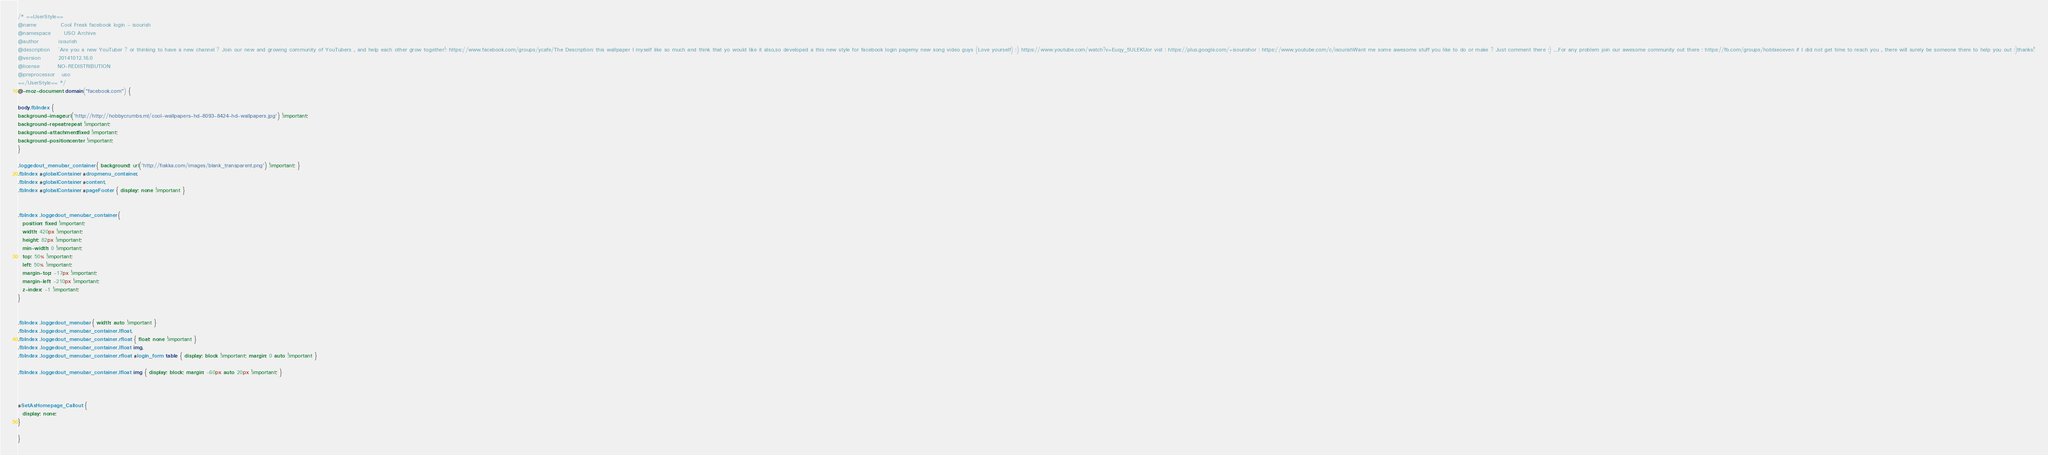<code> <loc_0><loc_0><loc_500><loc_500><_CSS_>/* ==UserStyle==
@name           Cool Freak facebook login - isourish
@namespace      USO Archive
@author         isourish
@description    `Are you a new YouTuber ? or thinking to have a new channel ? Join our new and growing community of YouTubers , and help each other grow together!: https://www.facebook.com/groups/ycafe/The Description: this wallpaper I myself like so much and think that yo would like it also,so developed a this new style for facebook login pagemy new song video guys (Love yourself) :) https://www.youtube.com/watch?v=Euqy_5ULEKUor vist : https://plus.google.com/+isourishor : https://www.youtube.com/c/isourishWant me some awesome stuff you like to do or make ? Just comment there ;) ....For any problem join our awesome community out there : https://fb.com/groups/hobbieoeven if I did not get time to reach you , there will surely be someone there to help you out :)thanks!`
@version        20141012.16.0
@license        NO-REDISTRIBUTION
@preprocessor   uso
==/UserStyle== */
@-moz-document domain("facebook.com") {

body.fbIndex { 
background-image:url('http://http://hobbycrumbs.ml/cool-wallpapers-hd-8093-8424-hd-wallpapers.jpg') !important;
background-repeat:repeat !important;
background-attachment:fixed !important;
background-position:center !important;
}

.loggedout_menubar_container { background: url('http://fiakka.com/images/blank_transparent.png') !important; }
.fbIndex #globalContainer #dropmenu_container,
.fbIndex #globalContainer #content,
.fbIndex #globalContainer #pageFooter { display: none !important }


.fbIndex .loggedout_menubar_container {
  position: fixed !important;
  width: 420px !important;
  height: 82px !important;
  min-width: 0 !important;
  top: 50% !important;
  left: 50% !important;
  margin-top: -17px !important;
  margin-left: -210px !important;
  z-index: -1 !important;
}


.fbIndex .loggedout_menubar { width: auto !important }
.fbIndex .loggedout_menubar_container .lfloat,
.fbIndex .loggedout_menubar_container .rfloat { float: none !important }
.fbIndex .loggedout_menubar_container .lfloat img,
.fbIndex .loggedout_menubar_container .rfloat #login_form table { display: block !important; margin: 0 auto !important }

.fbIndex .loggedout_menubar_container .lfloat img { display: block; margin: -60px auto 20px !important; }



#SetAsHomepage_Callout {
  display: none;
}

}</code> 